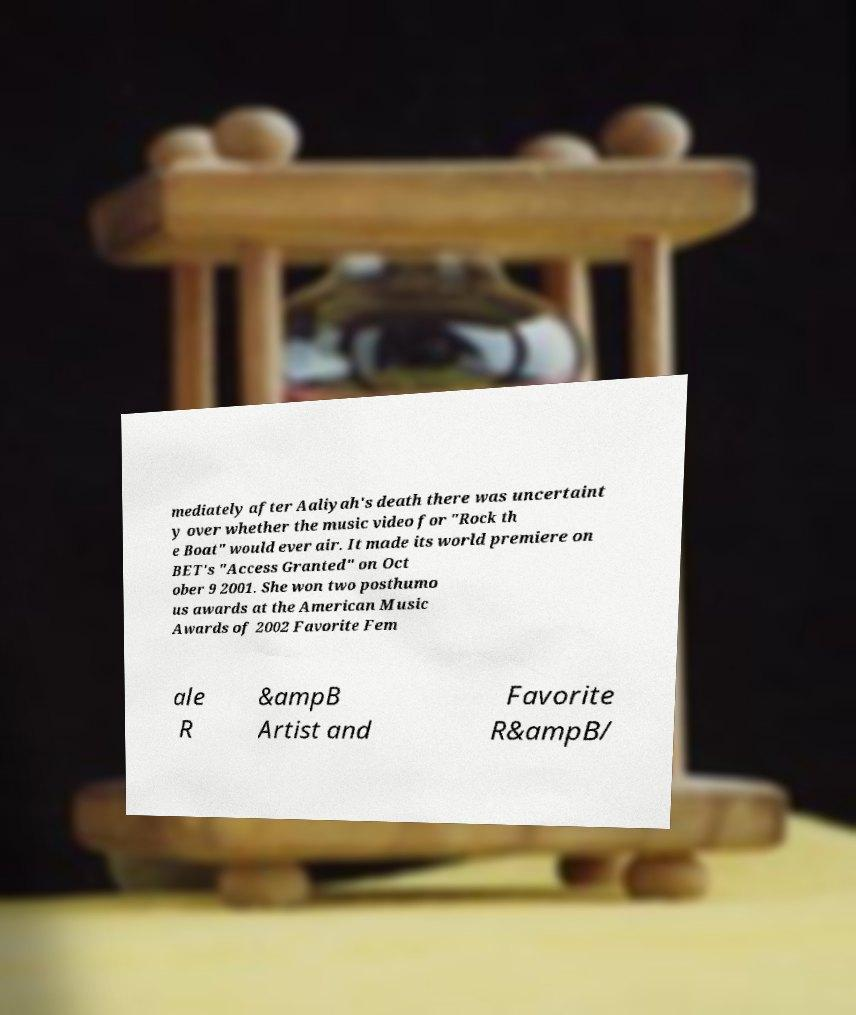Could you assist in decoding the text presented in this image and type it out clearly? mediately after Aaliyah's death there was uncertaint y over whether the music video for "Rock th e Boat" would ever air. It made its world premiere on BET's "Access Granted" on Oct ober 9 2001. She won two posthumo us awards at the American Music Awards of 2002 Favorite Fem ale R &ampB Artist and Favorite R&ampB/ 